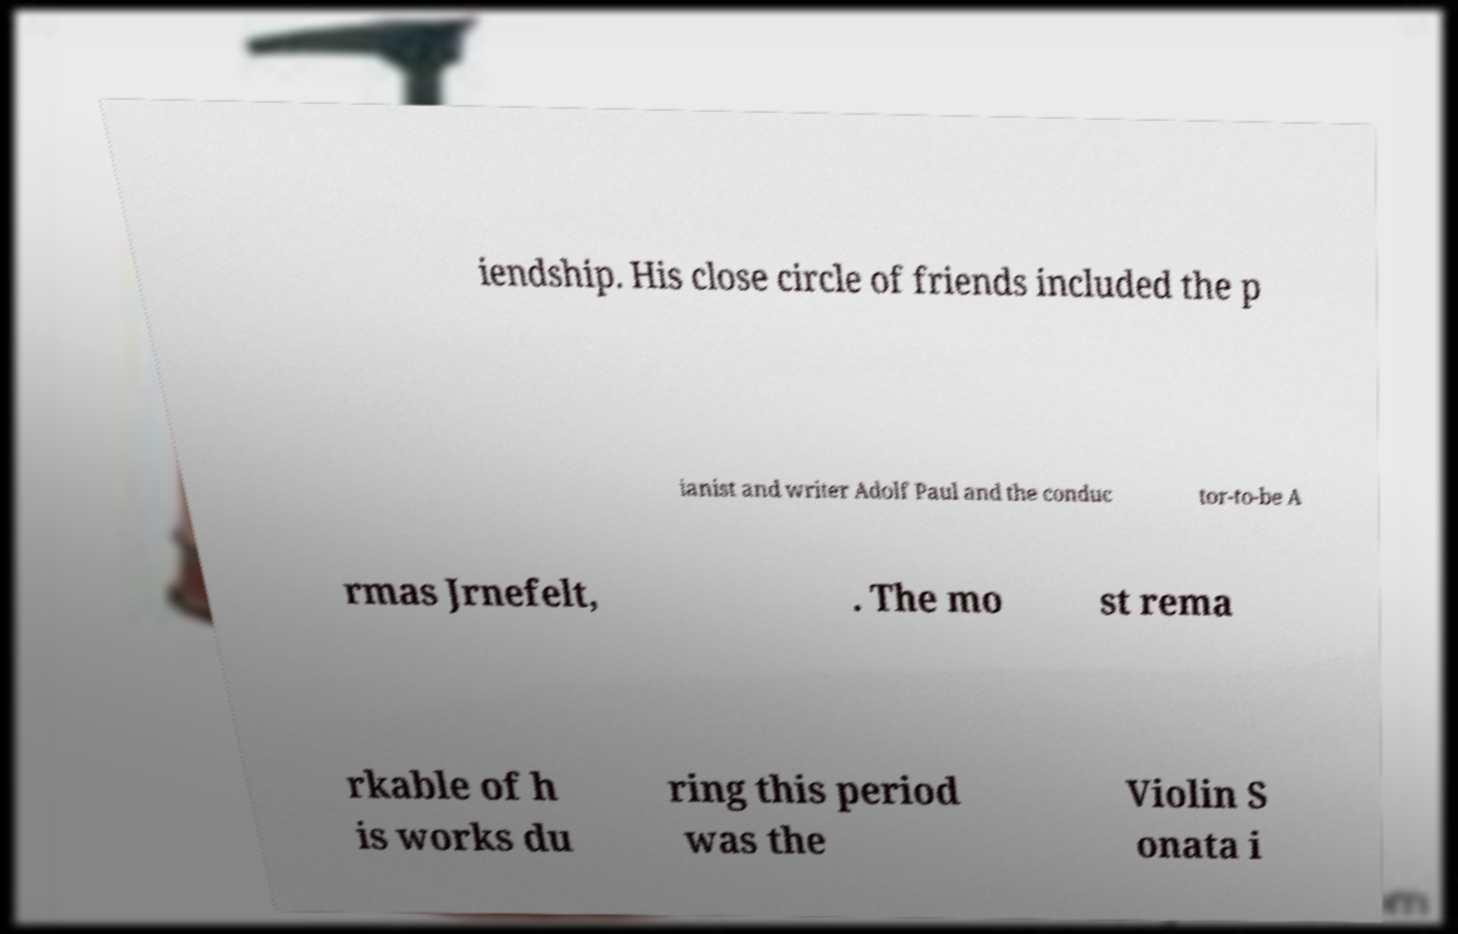Please read and relay the text visible in this image. What does it say? iendship. His close circle of friends included the p ianist and writer Adolf Paul and the conduc tor-to-be A rmas Jrnefelt, . The mo st rema rkable of h is works du ring this period was the Violin S onata i 